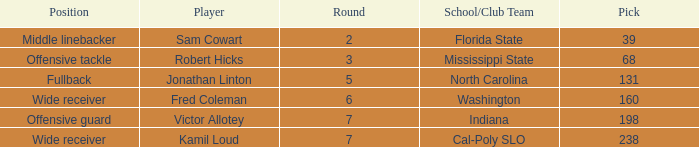Which Round has a School/Club Team of north carolina, and a Pick larger than 131? 0.0. 